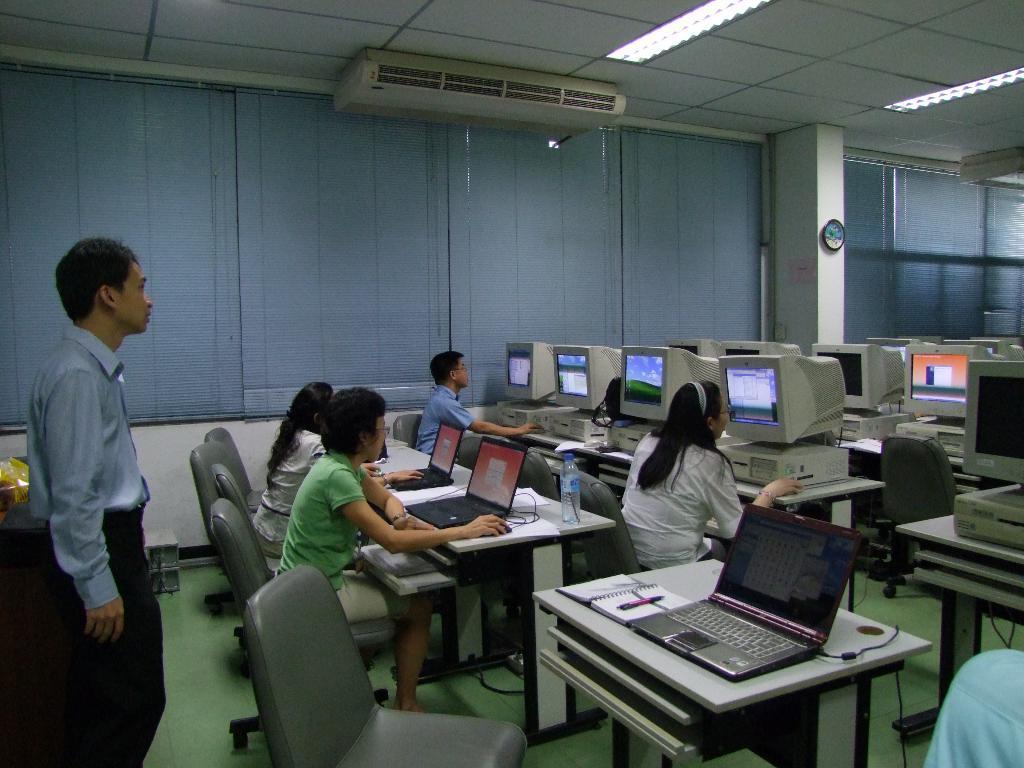Describe this image in one or two sentences. The image is inside the room. In the image there are group of people sitting on chair in front of a table, on table we can see mouse,laptop,water bottle,computer. On left there is a man standing near the table in background there is a window which is closed and roof on top with few lights. 